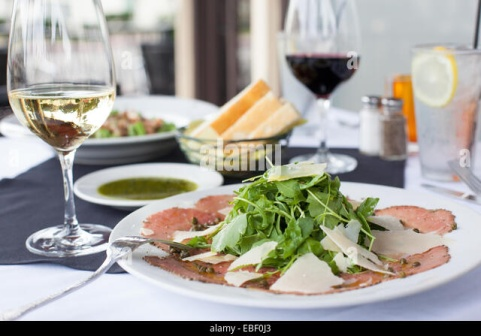Given the setting, what might happen in the next few moments? In the next few moments, the scene subtly shifts as the diners prepare to savor their meal. The person sits down, picks up the fork with a sense of anticipation, and delicately cuts through the tender carpaccio. The aroma of fresh arugula and Parmesan fills the air, mingling with the rich scent of olive oil. They take a bite, savoring the harmony of flavors, while the first sip of wine complements the dish perfectly. The experience is savored in quiet contentment, marking the beginning of a delightful dining experience. 